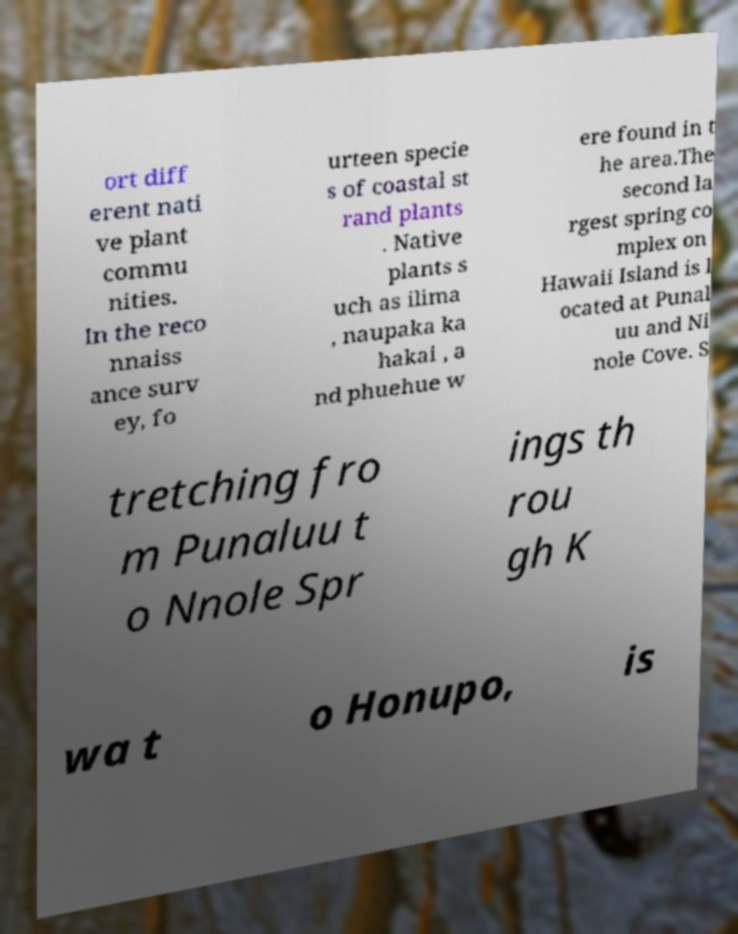Please identify and transcribe the text found in this image. ort diff erent nati ve plant commu nities. In the reco nnaiss ance surv ey, fo urteen specie s of coastal st rand plants . Native plants s uch as ilima , naupaka ka hakai , a nd phuehue w ere found in t he area.The second la rgest spring co mplex on Hawaii Island is l ocated at Punal uu and Ni nole Cove. S tretching fro m Punaluu t o Nnole Spr ings th rou gh K wa t o Honupo, is 